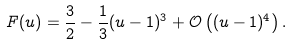Convert formula to latex. <formula><loc_0><loc_0><loc_500><loc_500>F ( u ) = \frac { 3 } { 2 } - \frac { 1 } { 3 } ( u - 1 ) ^ { 3 } + \mathcal { O } \left ( ( u - 1 ) ^ { 4 } \right ) .</formula> 